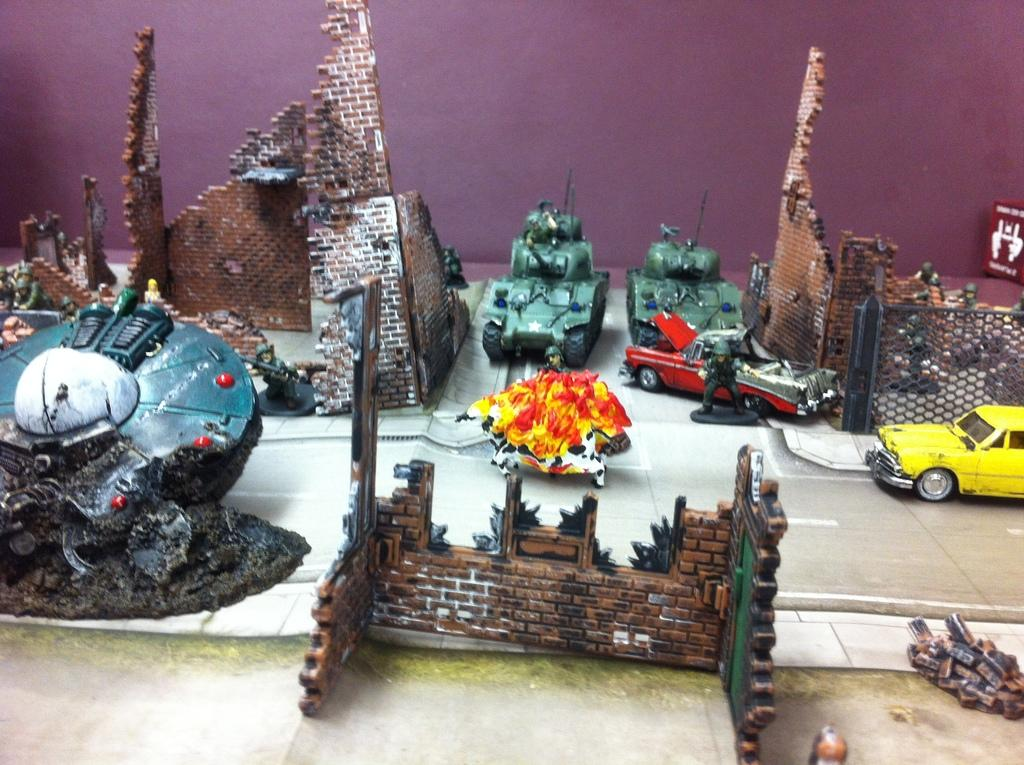What is the main subject of the image? The main subject of the image is a group of toys. Where are the toys located in the image? The toys are on a surface in the image. What can be seen in the background of the image? There is a wall in the background of the image. What type of rod can be seen in the image? There is no rod present in the image; it features a group of toys on a surface with a wall in the background. 